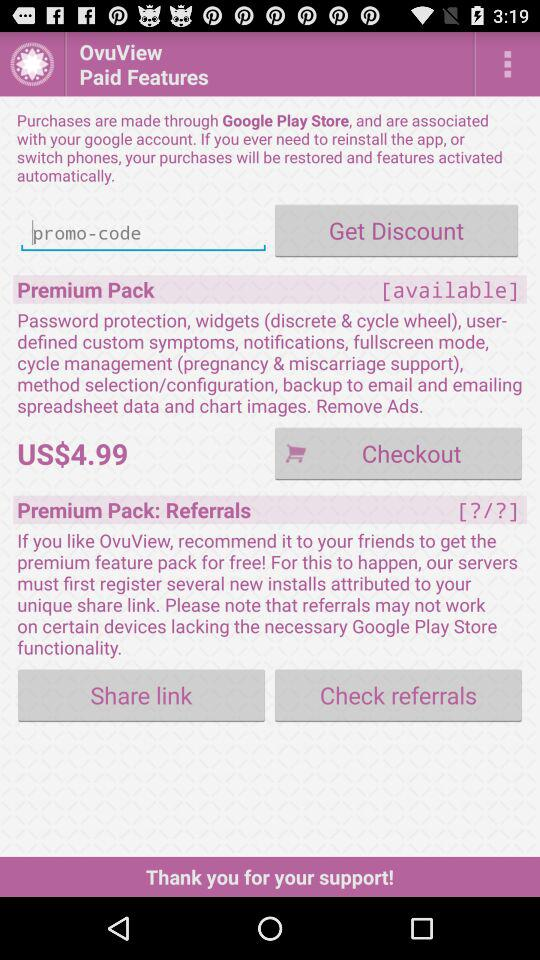What is the status of premium pack? The status of premium pack is "[available]". 